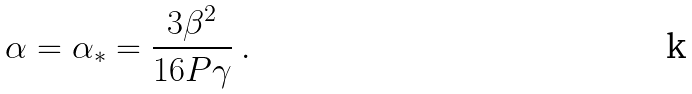<formula> <loc_0><loc_0><loc_500><loc_500>\alpha = \alpha _ { * } = \frac { 3 \beta ^ { 2 } } { 1 6 P \gamma } \ .</formula> 